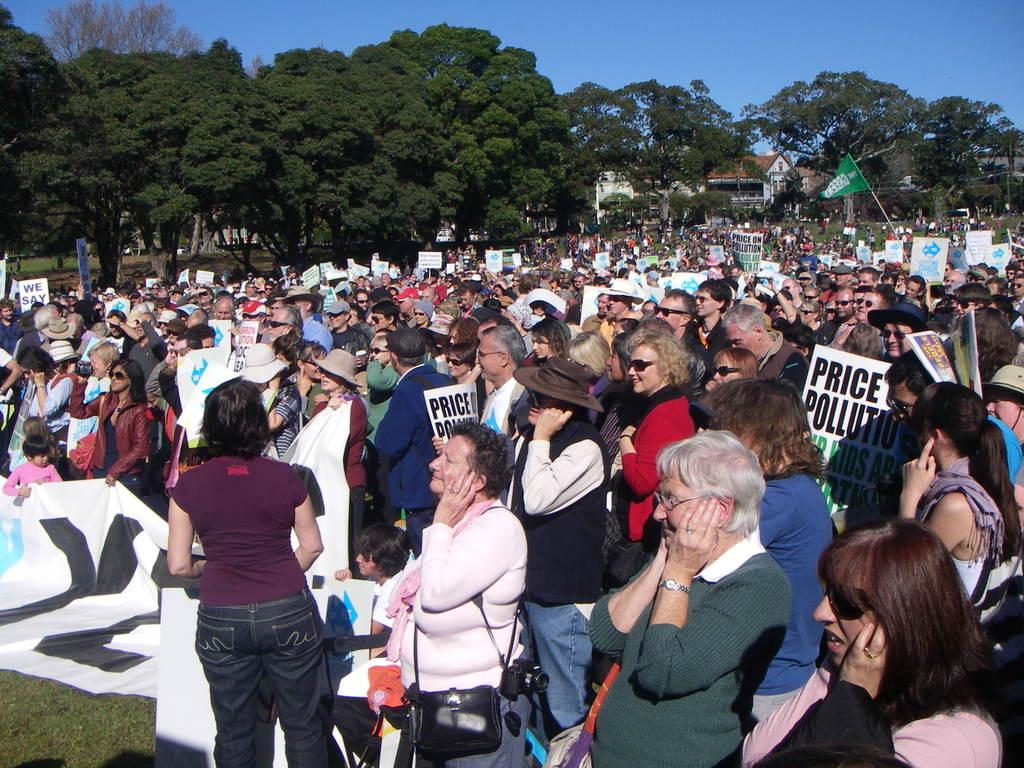What are the people in the image doing? The people in the image are standing and holding posters. What can be seen in the background of the image? There are green color trees in the image. What is the color of the sky in the image? The sky is blue in the image. How much sugar is present in the image? There is no reference to sugar in the image, so it cannot be determined how much sugar is present. 